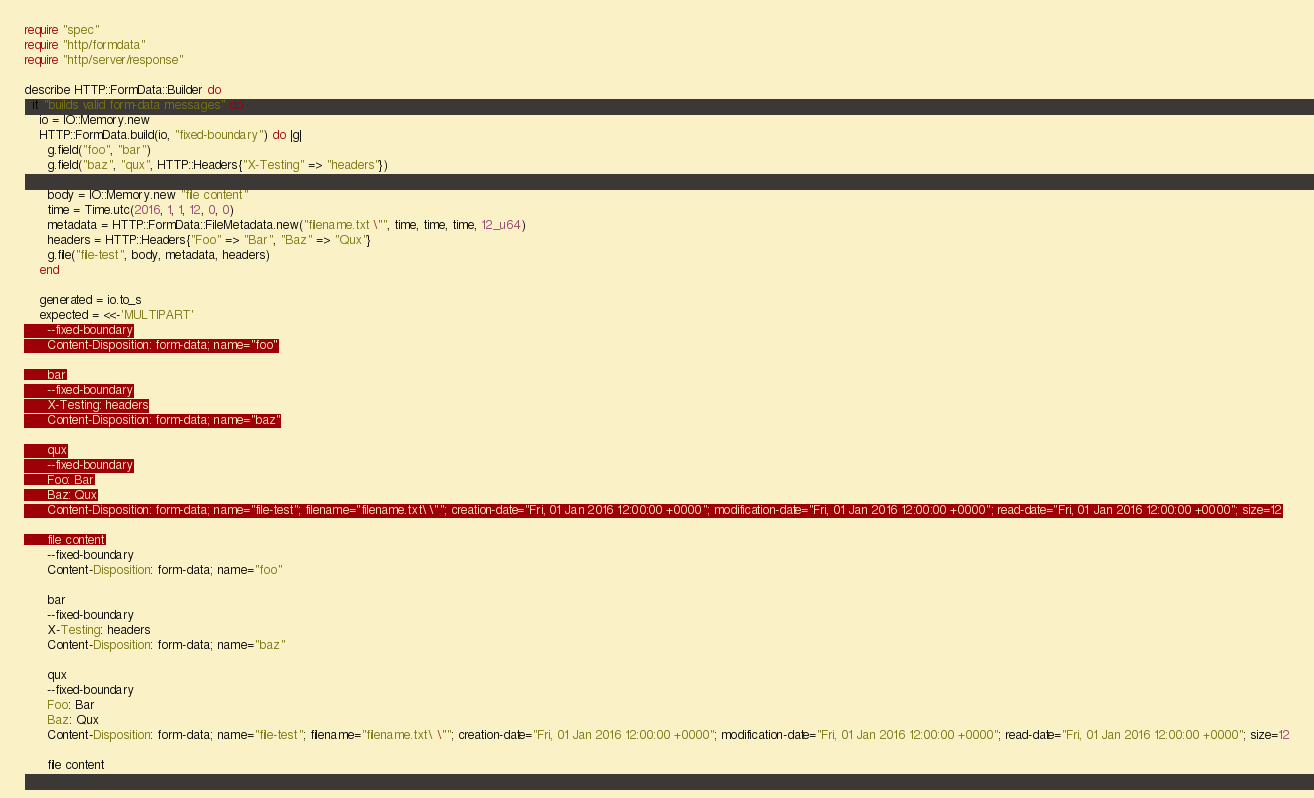<code> <loc_0><loc_0><loc_500><loc_500><_Crystal_>require "spec"
require "http/formdata"
require "http/server/response"

describe HTTP::FormData::Builder do
  it "builds valid form-data messages" do
    io = IO::Memory.new
    HTTP::FormData.build(io, "fixed-boundary") do |g|
      g.field("foo", "bar")
      g.field("baz", "qux", HTTP::Headers{"X-Testing" => "headers"})

      body = IO::Memory.new "file content"
      time = Time.utc(2016, 1, 1, 12, 0, 0)
      metadata = HTTP::FormData::FileMetadata.new("filename.txt \"", time, time, time, 12_u64)
      headers = HTTP::Headers{"Foo" => "Bar", "Baz" => "Qux"}
      g.file("file-test", body, metadata, headers)
    end

    generated = io.to_s
    expected = <<-'MULTIPART'
      --fixed-boundary
      Content-Disposition: form-data; name="foo"

      bar
      --fixed-boundary
      X-Testing: headers
      Content-Disposition: form-data; name="baz"

      qux
      --fixed-boundary
      Foo: Bar
      Baz: Qux
      Content-Disposition: form-data; name="file-test"; filename="filename.txt\ \""; creation-date="Fri, 01 Jan 2016 12:00:00 +0000"; modification-date="Fri, 01 Jan 2016 12:00:00 +0000"; read-date="Fri, 01 Jan 2016 12:00:00 +0000"; size=12

      file content</code> 